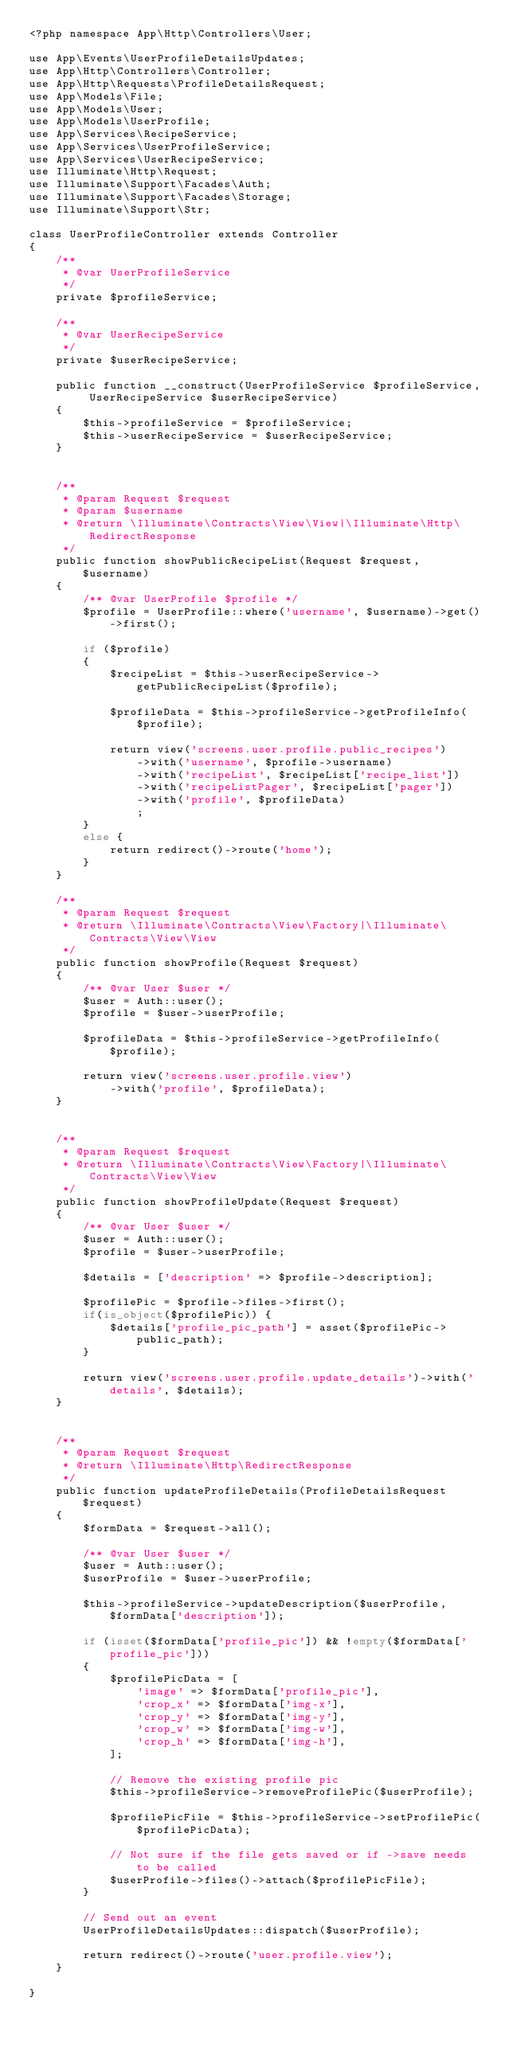Convert code to text. <code><loc_0><loc_0><loc_500><loc_500><_PHP_><?php namespace App\Http\Controllers\User;

use App\Events\UserProfileDetailsUpdates;
use App\Http\Controllers\Controller;
use App\Http\Requests\ProfileDetailsRequest;
use App\Models\File;
use App\Models\User;
use App\Models\UserProfile;
use App\Services\RecipeService;
use App\Services\UserProfileService;
use App\Services\UserRecipeService;
use Illuminate\Http\Request;
use Illuminate\Support\Facades\Auth;
use Illuminate\Support\Facades\Storage;
use Illuminate\Support\Str;

class UserProfileController extends Controller
{
    /**
     * @var UserProfileService
     */
    private $profileService;

    /**
     * @var UserRecipeService
     */
    private $userRecipeService;

    public function __construct(UserProfileService $profileService, UserRecipeService $userRecipeService)
    {
        $this->profileService = $profileService;
        $this->userRecipeService = $userRecipeService;
    }


    /**
     * @param Request $request
     * @param $username
     * @return \Illuminate\Contracts\View\View|\Illuminate\Http\RedirectResponse
     */
    public function showPublicRecipeList(Request $request, $username)
    {
        /** @var UserProfile $profile */
        $profile = UserProfile::where('username', $username)->get()->first();

        if ($profile)
        {
            $recipeList = $this->userRecipeService->getPublicRecipeList($profile);

            $profileData = $this->profileService->getProfileInfo($profile);

            return view('screens.user.profile.public_recipes')
                ->with('username', $profile->username)
                ->with('recipeList', $recipeList['recipe_list'])
                ->with('recipeListPager', $recipeList['pager'])
                ->with('profile', $profileData)
                ;
        }
        else {
            return redirect()->route('home');
        }
    }

    /**
     * @param Request $request
     * @return \Illuminate\Contracts\View\Factory|\Illuminate\Contracts\View\View
     */
    public function showProfile(Request $request)
    {
        /** @var User $user */
        $user = Auth::user();
        $profile = $user->userProfile;

        $profileData = $this->profileService->getProfileInfo($profile);

        return view('screens.user.profile.view')
            ->with('profile', $profileData);
    }


    /**
     * @param Request $request
     * @return \Illuminate\Contracts\View\Factory|\Illuminate\Contracts\View\View
     */
    public function showProfileUpdate(Request $request)
    {
        /** @var User $user */
        $user = Auth::user();
        $profile = $user->userProfile;

        $details = ['description' => $profile->description];

        $profilePic = $profile->files->first();
        if(is_object($profilePic)) {
            $details['profile_pic_path'] = asset($profilePic->public_path);
        }

        return view('screens.user.profile.update_details')->with('details', $details);
    }


    /**
     * @param Request $request
     * @return \Illuminate\Http\RedirectResponse
     */
    public function updateProfileDetails(ProfileDetailsRequest $request)
    {
        $formData = $request->all();

        /** @var User $user */
        $user = Auth::user();
        $userProfile = $user->userProfile;

        $this->profileService->updateDescription($userProfile, $formData['description']);

        if (isset($formData['profile_pic']) && !empty($formData['profile_pic']))
        {
            $profilePicData = [
                'image' => $formData['profile_pic'],
                'crop_x' => $formData['img-x'],
                'crop_y' => $formData['img-y'],
                'crop_w' => $formData['img-w'],
                'crop_h' => $formData['img-h'],
            ];

            // Remove the existing profile pic
            $this->profileService->removeProfilePic($userProfile);

            $profilePicFile = $this->profileService->setProfilePic($profilePicData);

            // Not sure if the file gets saved or if ->save needs to be called
            $userProfile->files()->attach($profilePicFile);
        }

        // Send out an event
        UserProfileDetailsUpdates::dispatch($userProfile);

        return redirect()->route('user.profile.view');
    }

}
</code> 